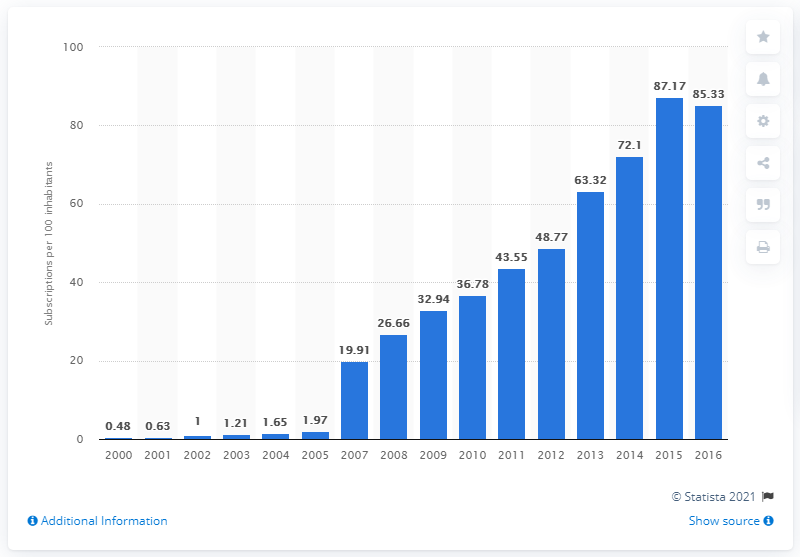List a handful of essential elements in this visual. In Guinea-Bissau, the number of mobile cellular subscriptions per 100 inhabitants was between 2000 and... During the period between 2000 and 2016, an average of 85.33 mobile subscriptions were registered for every 100 people in Guinea-Bissau. 